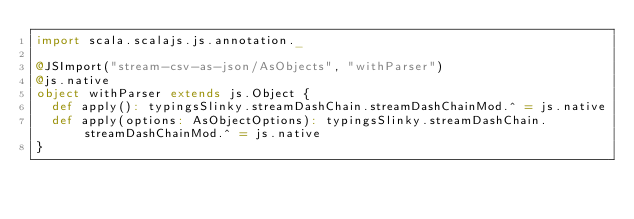Convert code to text. <code><loc_0><loc_0><loc_500><loc_500><_Scala_>import scala.scalajs.js.annotation._

@JSImport("stream-csv-as-json/AsObjects", "withParser")
@js.native
object withParser extends js.Object {
  def apply(): typingsSlinky.streamDashChain.streamDashChainMod.^ = js.native
  def apply(options: AsObjectOptions): typingsSlinky.streamDashChain.streamDashChainMod.^ = js.native
}

</code> 